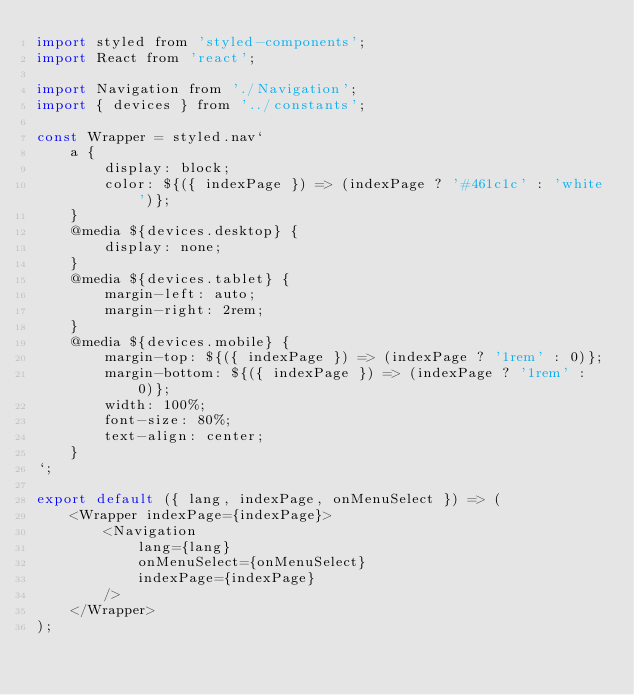Convert code to text. <code><loc_0><loc_0><loc_500><loc_500><_JavaScript_>import styled from 'styled-components';
import React from 'react';

import Navigation from './Navigation';
import { devices } from '../constants';

const Wrapper = styled.nav`
    a {
        display: block;
        color: ${({ indexPage }) => (indexPage ? '#461c1c' : 'white')};
    }
    @media ${devices.desktop} {
        display: none;
    }
    @media ${devices.tablet} {
        margin-left: auto;
        margin-right: 2rem;
    }
    @media ${devices.mobile} {
        margin-top: ${({ indexPage }) => (indexPage ? '1rem' : 0)};
        margin-bottom: ${({ indexPage }) => (indexPage ? '1rem' : 0)};
        width: 100%;
        font-size: 80%;
        text-align: center;
    }
`;

export default ({ lang, indexPage, onMenuSelect }) => (
    <Wrapper indexPage={indexPage}>
        <Navigation
            lang={lang}
            onMenuSelect={onMenuSelect}
            indexPage={indexPage}
        />
    </Wrapper>
);
</code> 